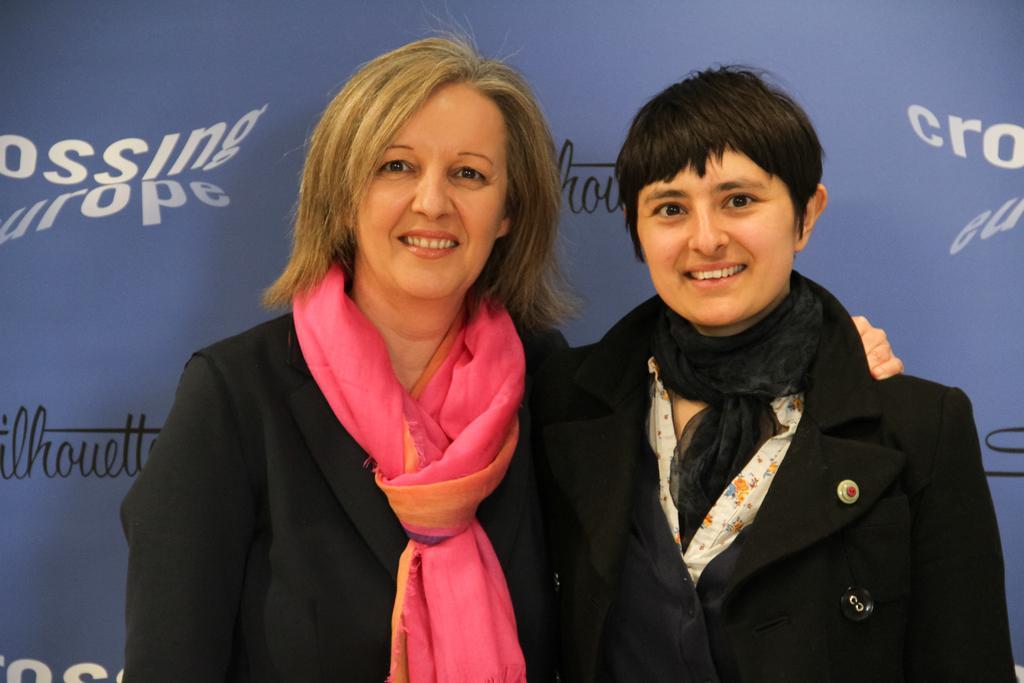How would you summarize this image in a sentence or two? In this picture there are two ladies in the center of the image and there is a poster in the background area of the image. 